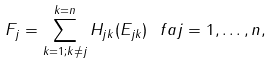<formula> <loc_0><loc_0><loc_500><loc_500>F _ { j } = \sum ^ { k = n } _ { k = 1 ; k \neq j } H _ { j k } ( E _ { j k } ) \ f a j = 1 , \dots , n ,</formula> 